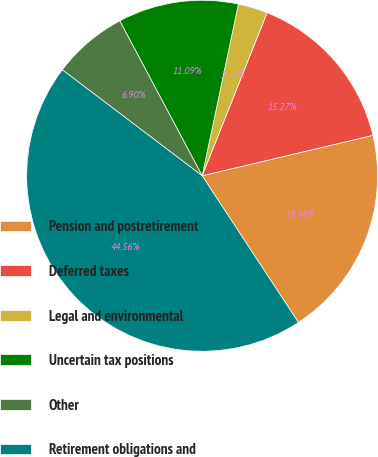<chart> <loc_0><loc_0><loc_500><loc_500><pie_chart><fcel>Pension and postretirement<fcel>Deferred taxes<fcel>Legal and environmental<fcel>Uncertain tax positions<fcel>Other<fcel>Retirement obligations and<nl><fcel>19.46%<fcel>15.27%<fcel>2.72%<fcel>11.09%<fcel>6.9%<fcel>44.56%<nl></chart> 